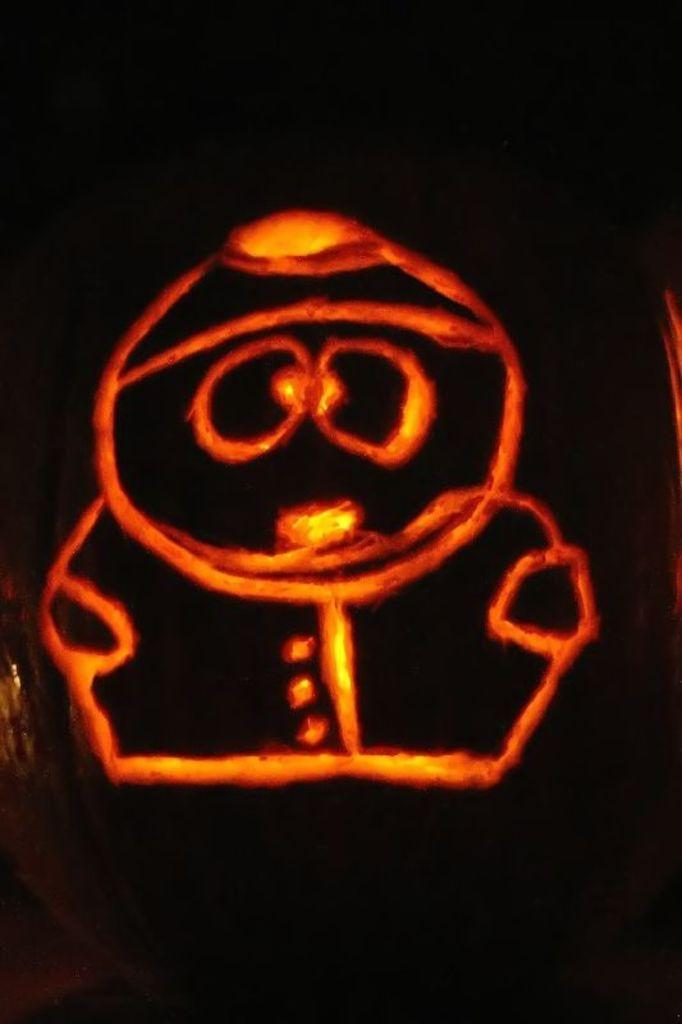What type of shoes can be seen on the face in the image? There is no face or shoes present in the image. 